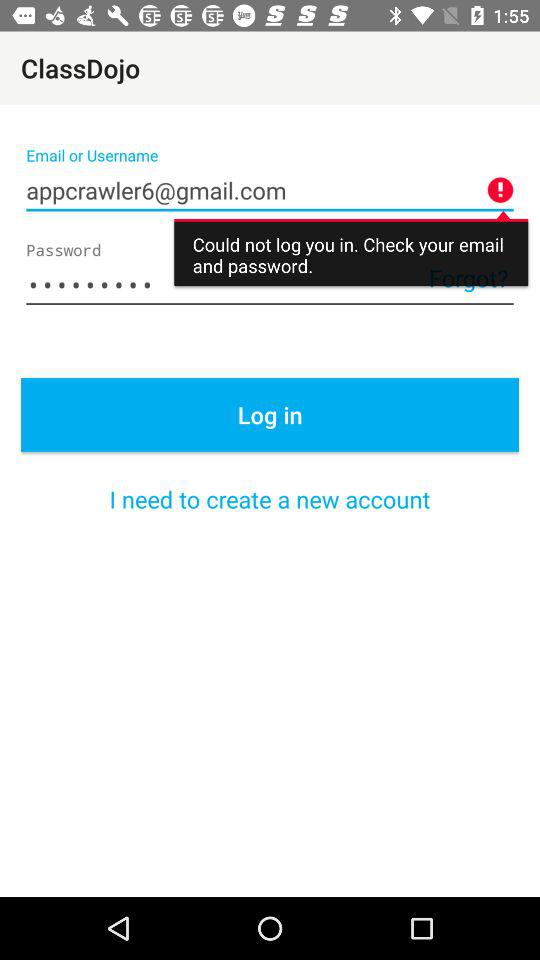What is the application name? The application name is "ClassDojo". 